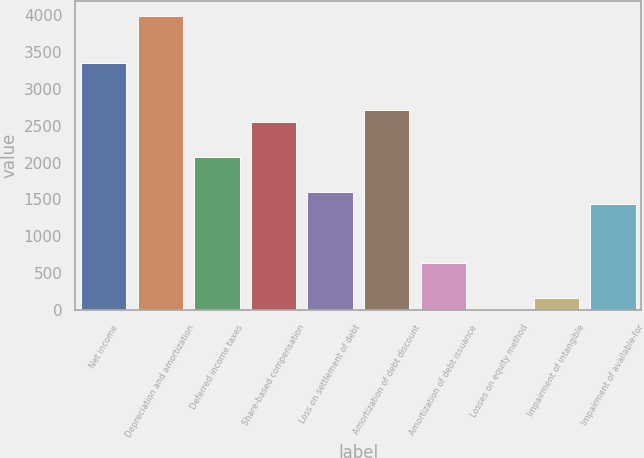Convert chart to OTSL. <chart><loc_0><loc_0><loc_500><loc_500><bar_chart><fcel>Net income<fcel>Depreciation and amortization<fcel>Deferred income taxes<fcel>Share-based compensation<fcel>Loss on settlement of debt<fcel>Amortization of debt discount<fcel>Amortization of debt issuance<fcel>Losses on equity method<fcel>Impairment of intangible<fcel>Impairment of available-for<nl><fcel>3348.86<fcel>3986.7<fcel>2073.18<fcel>2551.56<fcel>1594.8<fcel>2711.02<fcel>638.04<fcel>0.2<fcel>159.66<fcel>1435.34<nl></chart> 